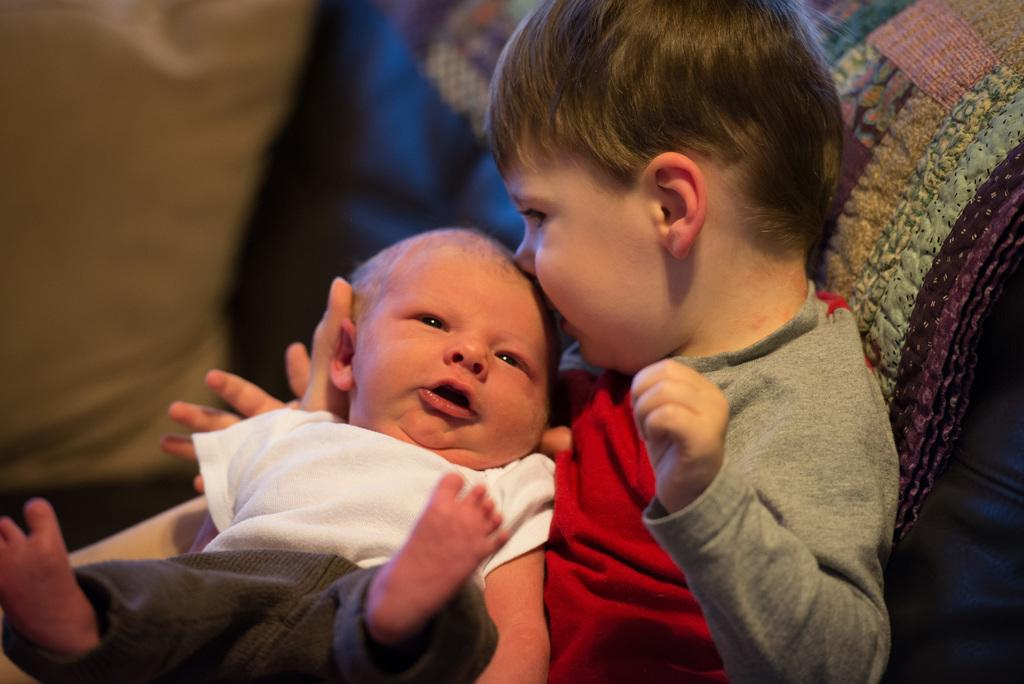What is the main subject of the image? The main subject of the image is a kid. What is the kid doing in the image? The kid is holding a baby. How can we differentiate the kid and the baby in the image? The kid and the baby are wearing different color dresses. Can you describe the background of the image? The background of the image is blurred. What type of print can be seen on the baby's skin in the image? There is no print visible on the baby's skin in the image. What month is depicted on the calendar in the image? There is no calendar present in the image. 